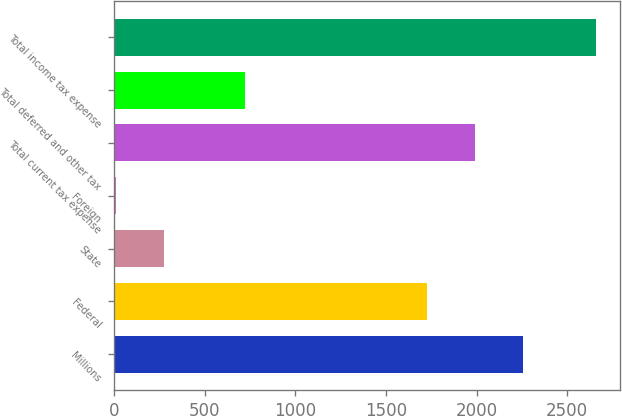<chart> <loc_0><loc_0><loc_500><loc_500><bar_chart><fcel>Millions<fcel>Federal<fcel>State<fcel>Foreign<fcel>Total current tax expense<fcel>Total deferred and other tax<fcel>Total income tax expense<nl><fcel>2256.8<fcel>1727<fcel>275.9<fcel>11<fcel>1991.9<fcel>723<fcel>2660<nl></chart> 